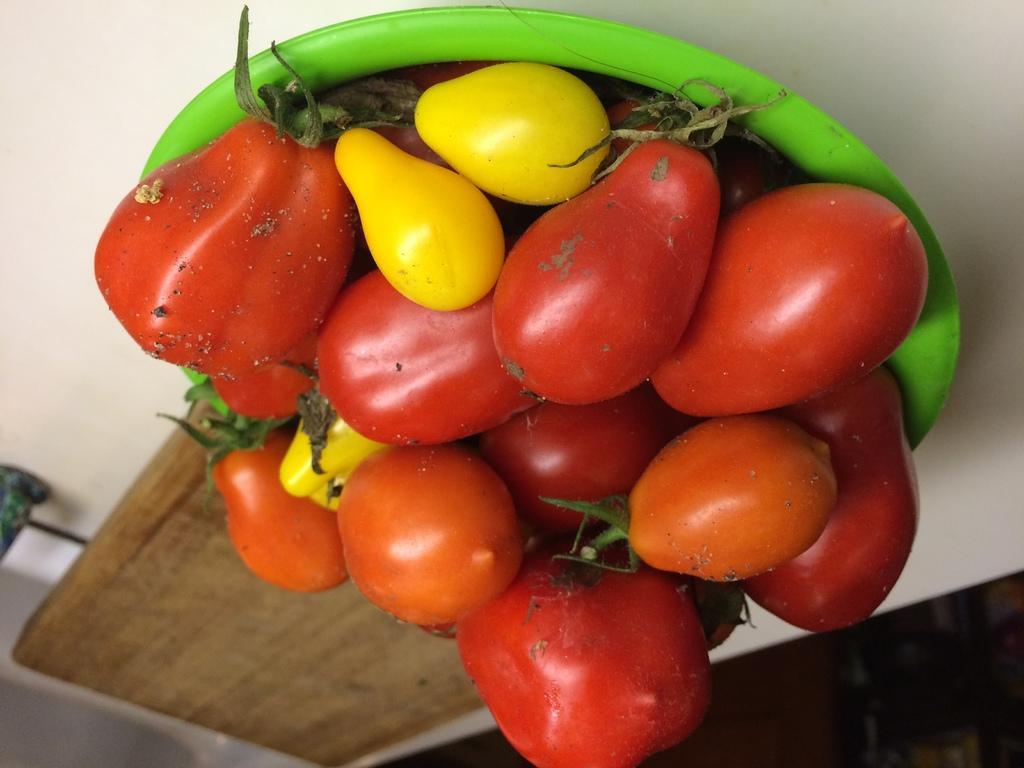Describe this image in one or two sentences. In this image there is a table and we can see a bowl containing tomatoes which are in red and yellow color. We can also see a tray placed on the table. 